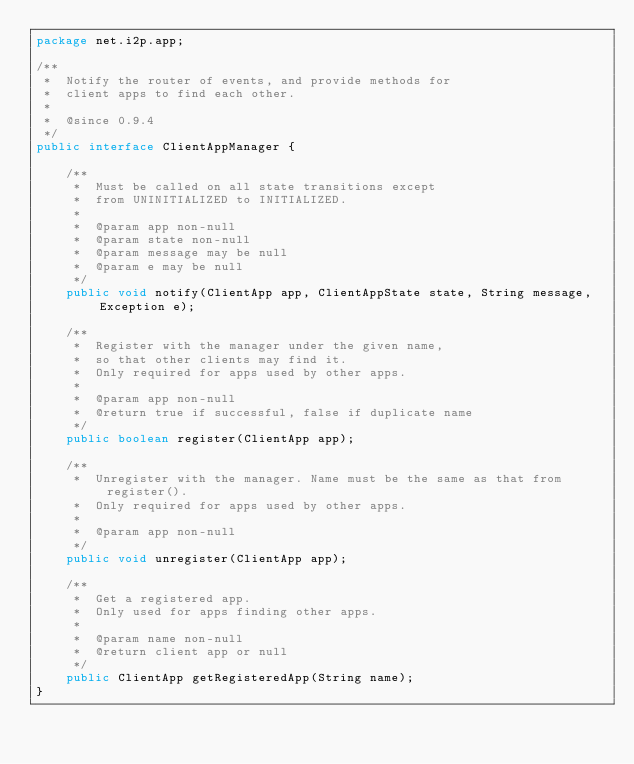Convert code to text. <code><loc_0><loc_0><loc_500><loc_500><_Java_>package net.i2p.app;

/**
 *  Notify the router of events, and provide methods for
 *  client apps to find each other.
 *
 *  @since 0.9.4
 */
public interface ClientAppManager {
    
    /**
     *  Must be called on all state transitions except
     *  from UNINITIALIZED to INITIALIZED.
     *
     *  @param app non-null
     *  @param state non-null
     *  @param message may be null
     *  @param e may be null
     */
    public void notify(ClientApp app, ClientAppState state, String message, Exception e);
    
    /**
     *  Register with the manager under the given name,
     *  so that other clients may find it.
     *  Only required for apps used by other apps.
     *
     *  @param app non-null
     *  @return true if successful, false if duplicate name
     */
    public boolean register(ClientApp app);
    
    /**
     *  Unregister with the manager. Name must be the same as that from register().
     *  Only required for apps used by other apps.
     *
     *  @param app non-null
     */
    public void unregister(ClientApp app);
    
    /**
     *  Get a registered app.
     *  Only used for apps finding other apps.
     *
     *  @param name non-null
     *  @return client app or null
     */
    public ClientApp getRegisteredApp(String name);
}
</code> 